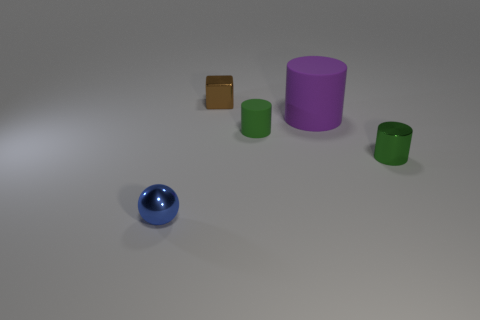Add 4 brown metallic blocks. How many objects exist? 9 Subtract all balls. How many objects are left? 4 Subtract 0 cyan blocks. How many objects are left? 5 Subtract all large purple matte things. Subtract all brown shiny objects. How many objects are left? 3 Add 5 spheres. How many spheres are left? 6 Add 5 metal spheres. How many metal spheres exist? 6 